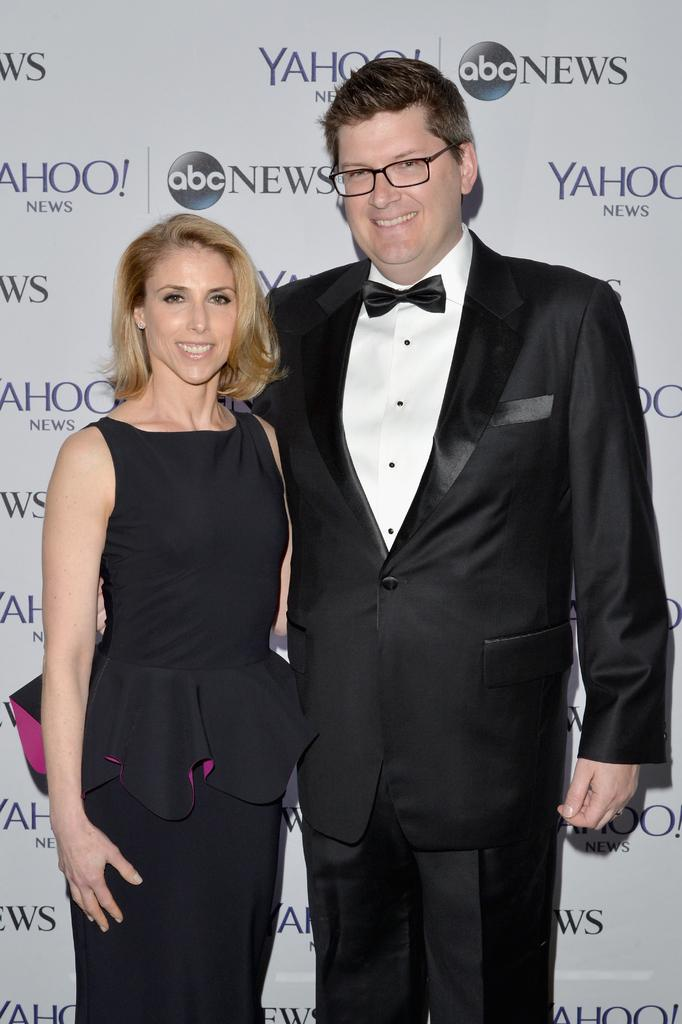<image>
Write a terse but informative summary of the picture. woman in a dress and a man in a suit stand in front of a yahoo and abc news advertisement. 